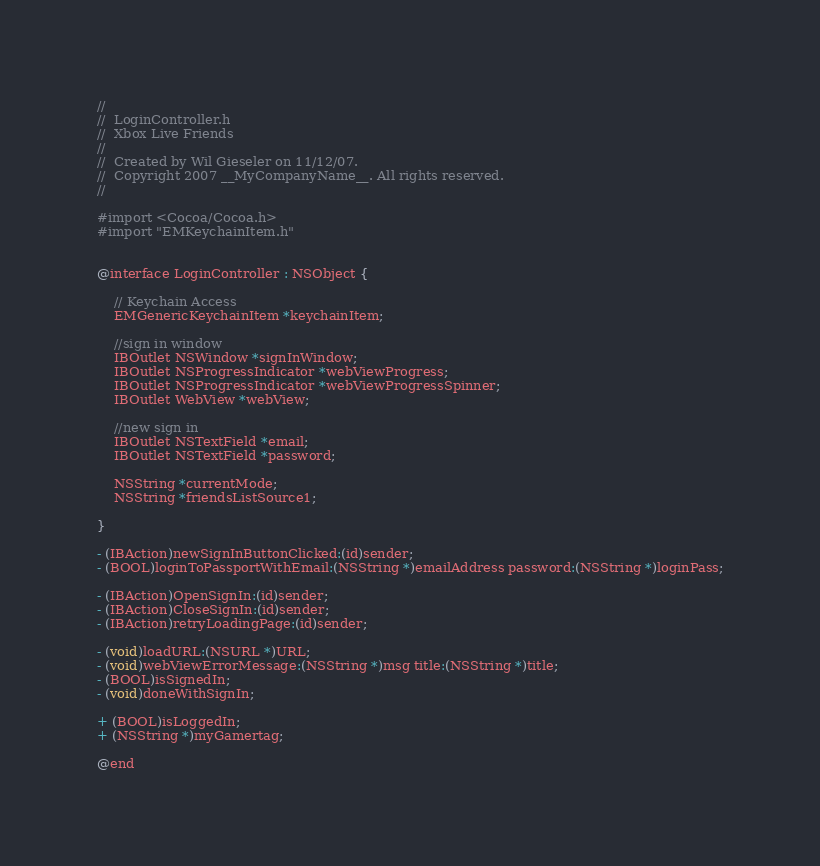<code> <loc_0><loc_0><loc_500><loc_500><_C_>//
//  LoginController.h
//  Xbox Live Friends
//
//  Created by Wil Gieseler on 11/12/07.
//  Copyright 2007 __MyCompanyName__. All rights reserved.
//

#import <Cocoa/Cocoa.h>
#import "EMKeychainItem.h"


@interface LoginController : NSObject {
	
	// Keychain Access
	EMGenericKeychainItem *keychainItem;

	//sign in window
	IBOutlet NSWindow *signInWindow;
	IBOutlet NSProgressIndicator *webViewProgress;
	IBOutlet NSProgressIndicator *webViewProgressSpinner;
    IBOutlet WebView *webView;
	
	//new sign in
	IBOutlet NSTextField *email;
	IBOutlet NSTextField *password;

	NSString *currentMode;
	NSString *friendsListSource1;

}

- (IBAction)newSignInButtonClicked:(id)sender;
- (BOOL)loginToPassportWithEmail:(NSString *)emailAddress password:(NSString *)loginPass;

- (IBAction)OpenSignIn:(id)sender;
- (IBAction)CloseSignIn:(id)sender;
- (IBAction)retryLoadingPage:(id)sender;

- (void)loadURL:(NSURL *)URL;
- (void)webViewErrorMessage:(NSString *)msg title:(NSString *)title;
- (BOOL)isSignedIn;
- (void)doneWithSignIn;

+ (BOOL)isLoggedIn;
+ (NSString *)myGamertag;

@end
</code> 